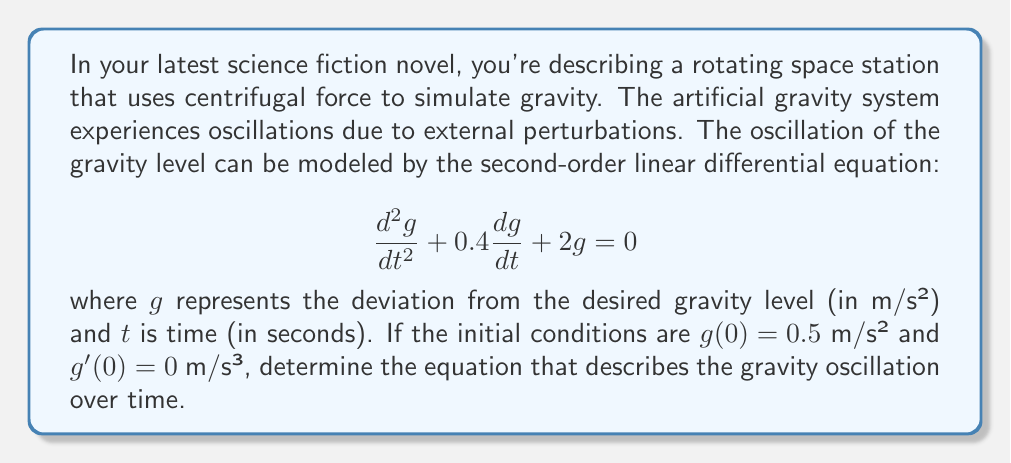What is the answer to this math problem? To solve this second-order linear differential equation, we follow these steps:

1) The characteristic equation for this differential equation is:
   $$r^2 + 0.4r + 2 = 0$$

2) Solve the characteristic equation:
   $$r = \frac{-0.4 \pm \sqrt{0.4^2 - 4(1)(2)}}{2(1)}$$
   $$r = \frac{-0.4 \pm \sqrt{0.16 - 8}}{2} = \frac{-0.4 \pm \sqrt{-7.84}}{2}$$
   $$r = -0.2 \pm 1.4i$$

3) The general solution is:
   $$g(t) = e^{-0.2t}(c_1\cos(1.4t) + c_2\sin(1.4t))$$

4) Use the initial conditions to find $c_1$ and $c_2$:
   For $g(0) = 0.5$: 
   $$0.5 = c_1$$

   For $g'(0) = 0$:
   $$g'(t) = e^{-0.2t}(-0.2c_1\cos(1.4t) - 0.2c_2\sin(1.4t) - 1.4c_1\sin(1.4t) + 1.4c_2\cos(1.4t))$$
   $$0 = -0.2c_1 + 1.4c_2$$
   $$0 = -0.2(0.5) + 1.4c_2$$
   $$c_2 = \frac{0.1}{1.4} \approx 0.0714$$

5) Substitute these values into the general solution:
   $$g(t) = e^{-0.2t}(0.5\cos(1.4t) + 0.0714\sin(1.4t))$$

This equation describes the oscillation of the artificial gravity system over time.
Answer: $$g(t) = e^{-0.2t}(0.5\cos(1.4t) + 0.0714\sin(1.4t))$$ 